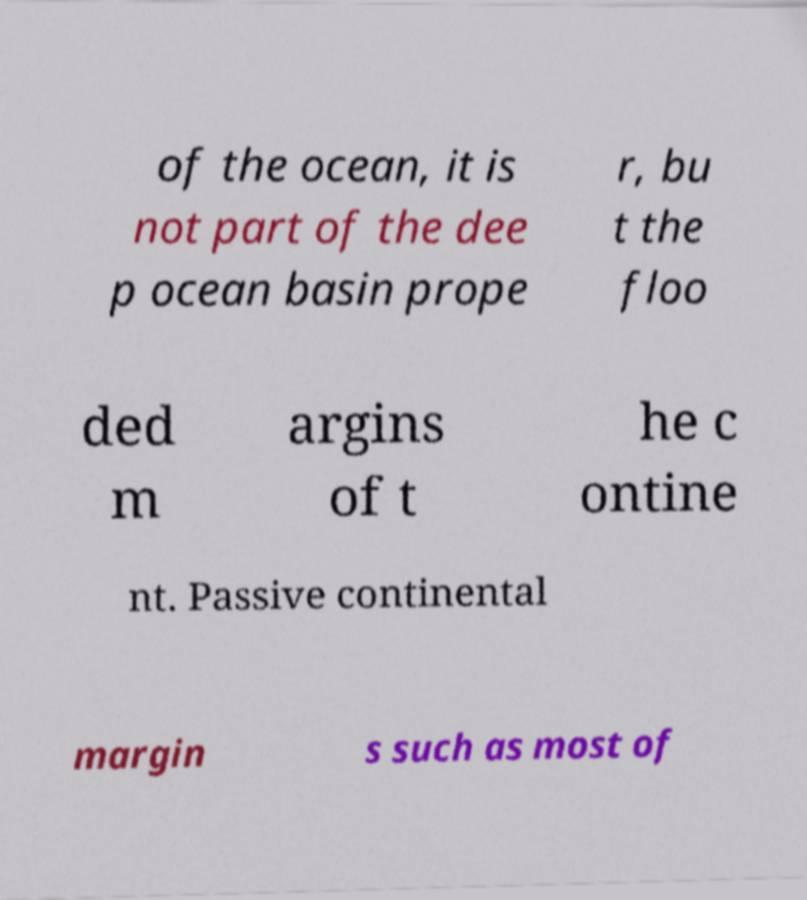What messages or text are displayed in this image? I need them in a readable, typed format. of the ocean, it is not part of the dee p ocean basin prope r, bu t the floo ded m argins of t he c ontine nt. Passive continental margin s such as most of 